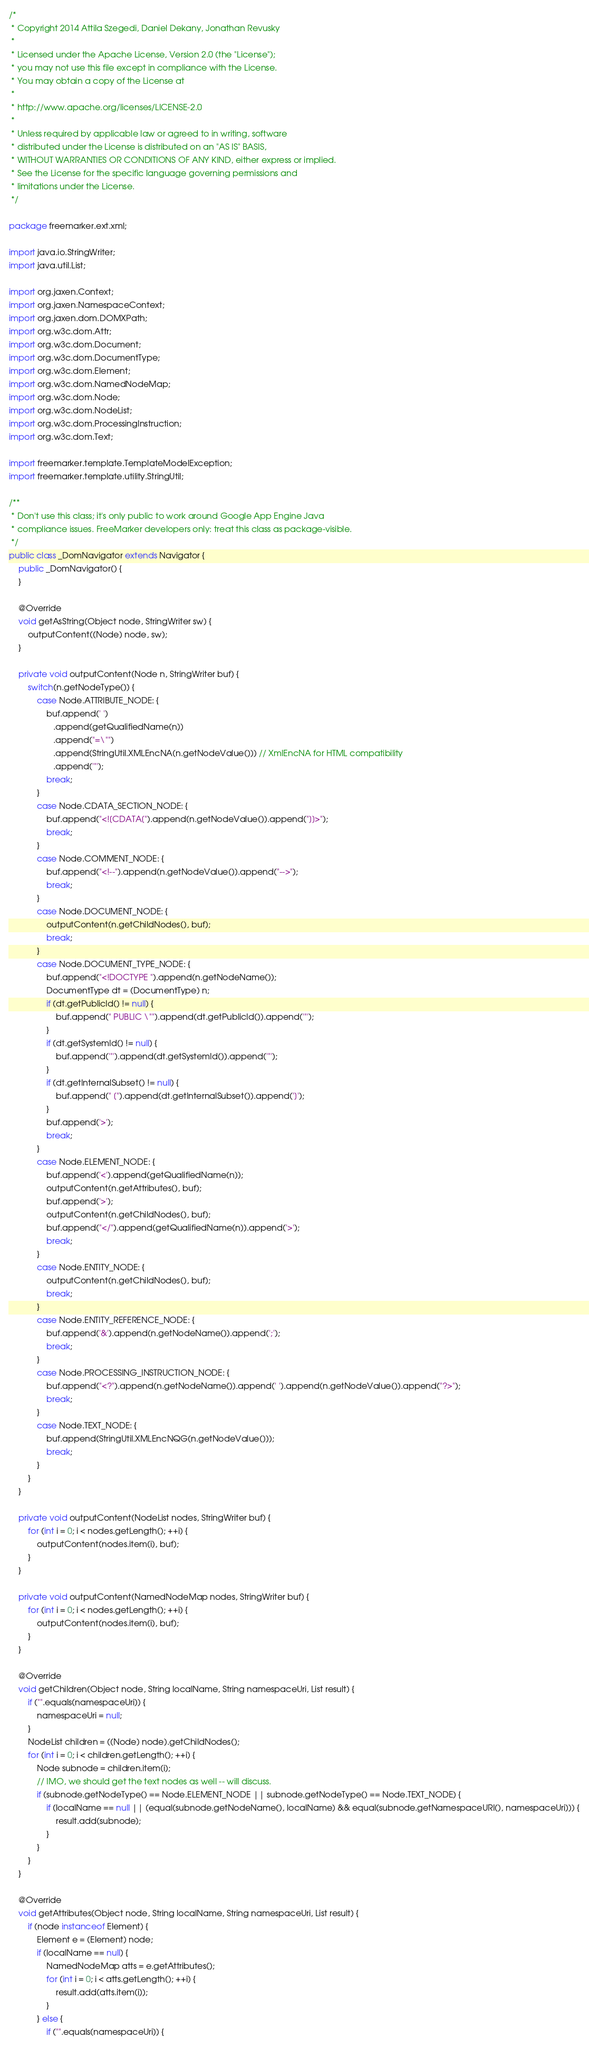<code> <loc_0><loc_0><loc_500><loc_500><_Java_>/*
 * Copyright 2014 Attila Szegedi, Daniel Dekany, Jonathan Revusky
 * 
 * Licensed under the Apache License, Version 2.0 (the "License");
 * you may not use this file except in compliance with the License.
 * You may obtain a copy of the License at
 * 
 * http://www.apache.org/licenses/LICENSE-2.0
 * 
 * Unless required by applicable law or agreed to in writing, software
 * distributed under the License is distributed on an "AS IS" BASIS,
 * WITHOUT WARRANTIES OR CONDITIONS OF ANY KIND, either express or implied.
 * See the License for the specific language governing permissions and
 * limitations under the License.
 */

package freemarker.ext.xml;

import java.io.StringWriter;
import java.util.List;

import org.jaxen.Context;
import org.jaxen.NamespaceContext;
import org.jaxen.dom.DOMXPath;
import org.w3c.dom.Attr;
import org.w3c.dom.Document;
import org.w3c.dom.DocumentType;
import org.w3c.dom.Element;
import org.w3c.dom.NamedNodeMap;
import org.w3c.dom.Node;
import org.w3c.dom.NodeList;
import org.w3c.dom.ProcessingInstruction;
import org.w3c.dom.Text;

import freemarker.template.TemplateModelException;
import freemarker.template.utility.StringUtil;

/**
 * Don't use this class; it's only public to work around Google App Engine Java
 * compliance issues. FreeMarker developers only: treat this class as package-visible.
 */
public class _DomNavigator extends Navigator {
    public _DomNavigator() {
    } 

    @Override
    void getAsString(Object node, StringWriter sw) {
        outputContent((Node) node, sw);
    }
    
    private void outputContent(Node n, StringWriter buf) {
        switch(n.getNodeType()) {
            case Node.ATTRIBUTE_NODE: {
                buf.append(' ')
                   .append(getQualifiedName(n))
                   .append("=\"")
                   .append(StringUtil.XMLEncNA(n.getNodeValue())) // XmlEncNA for HTML compatibility
                   .append('"');
                break;
            }
            case Node.CDATA_SECTION_NODE: {
                buf.append("<![CDATA[").append(n.getNodeValue()).append("]]>");
                break;
            }
            case Node.COMMENT_NODE: {
                buf.append("<!--").append(n.getNodeValue()).append("-->");
                break;
            }
            case Node.DOCUMENT_NODE: {
                outputContent(n.getChildNodes(), buf);
                break;
            }
            case Node.DOCUMENT_TYPE_NODE: {
                buf.append("<!DOCTYPE ").append(n.getNodeName());
                DocumentType dt = (DocumentType) n;
                if (dt.getPublicId() != null) {
                    buf.append(" PUBLIC \"").append(dt.getPublicId()).append('"');
                }
                if (dt.getSystemId() != null) {
                    buf.append('"').append(dt.getSystemId()).append('"');
                }
                if (dt.getInternalSubset() != null) {
                    buf.append(" [").append(dt.getInternalSubset()).append(']');
                }
                buf.append('>');
                break;
            }
            case Node.ELEMENT_NODE: {
                buf.append('<').append(getQualifiedName(n));
                outputContent(n.getAttributes(), buf);
                buf.append('>');
                outputContent(n.getChildNodes(), buf);
                buf.append("</").append(getQualifiedName(n)).append('>');
                break;
            }
            case Node.ENTITY_NODE: {
                outputContent(n.getChildNodes(), buf);
                break;
            }
            case Node.ENTITY_REFERENCE_NODE: {
                buf.append('&').append(n.getNodeName()).append(';');
                break;
            }
            case Node.PROCESSING_INSTRUCTION_NODE: {
                buf.append("<?").append(n.getNodeName()).append(' ').append(n.getNodeValue()).append("?>");
                break;
            }
            case Node.TEXT_NODE: {
                buf.append(StringUtil.XMLEncNQG(n.getNodeValue()));
                break;
            }
        }
    }

    private void outputContent(NodeList nodes, StringWriter buf) {
        for (int i = 0; i < nodes.getLength(); ++i) {
            outputContent(nodes.item(i), buf);
        }
    }
    
    private void outputContent(NamedNodeMap nodes, StringWriter buf) {
        for (int i = 0; i < nodes.getLength(); ++i) {
            outputContent(nodes.item(i), buf);
        }
    }
    
    @Override
    void getChildren(Object node, String localName, String namespaceUri, List result) {
        if ("".equals(namespaceUri)) {
            namespaceUri = null;
        }
        NodeList children = ((Node) node).getChildNodes();
        for (int i = 0; i < children.getLength(); ++i) {
            Node subnode = children.item(i);
            // IMO, we should get the text nodes as well -- will discuss.
            if (subnode.getNodeType() == Node.ELEMENT_NODE || subnode.getNodeType() == Node.TEXT_NODE) {
                if (localName == null || (equal(subnode.getNodeName(), localName) && equal(subnode.getNamespaceURI(), namespaceUri))) {
                    result.add(subnode);
                }
            }
        }
    }
    
    @Override
    void getAttributes(Object node, String localName, String namespaceUri, List result) {
        if (node instanceof Element) {
            Element e = (Element) node;
            if (localName == null) {
                NamedNodeMap atts = e.getAttributes();
                for (int i = 0; i < atts.getLength(); ++i) {
                    result.add(atts.item(i));
                }
            } else {
                if ("".equals(namespaceUri)) {</code> 